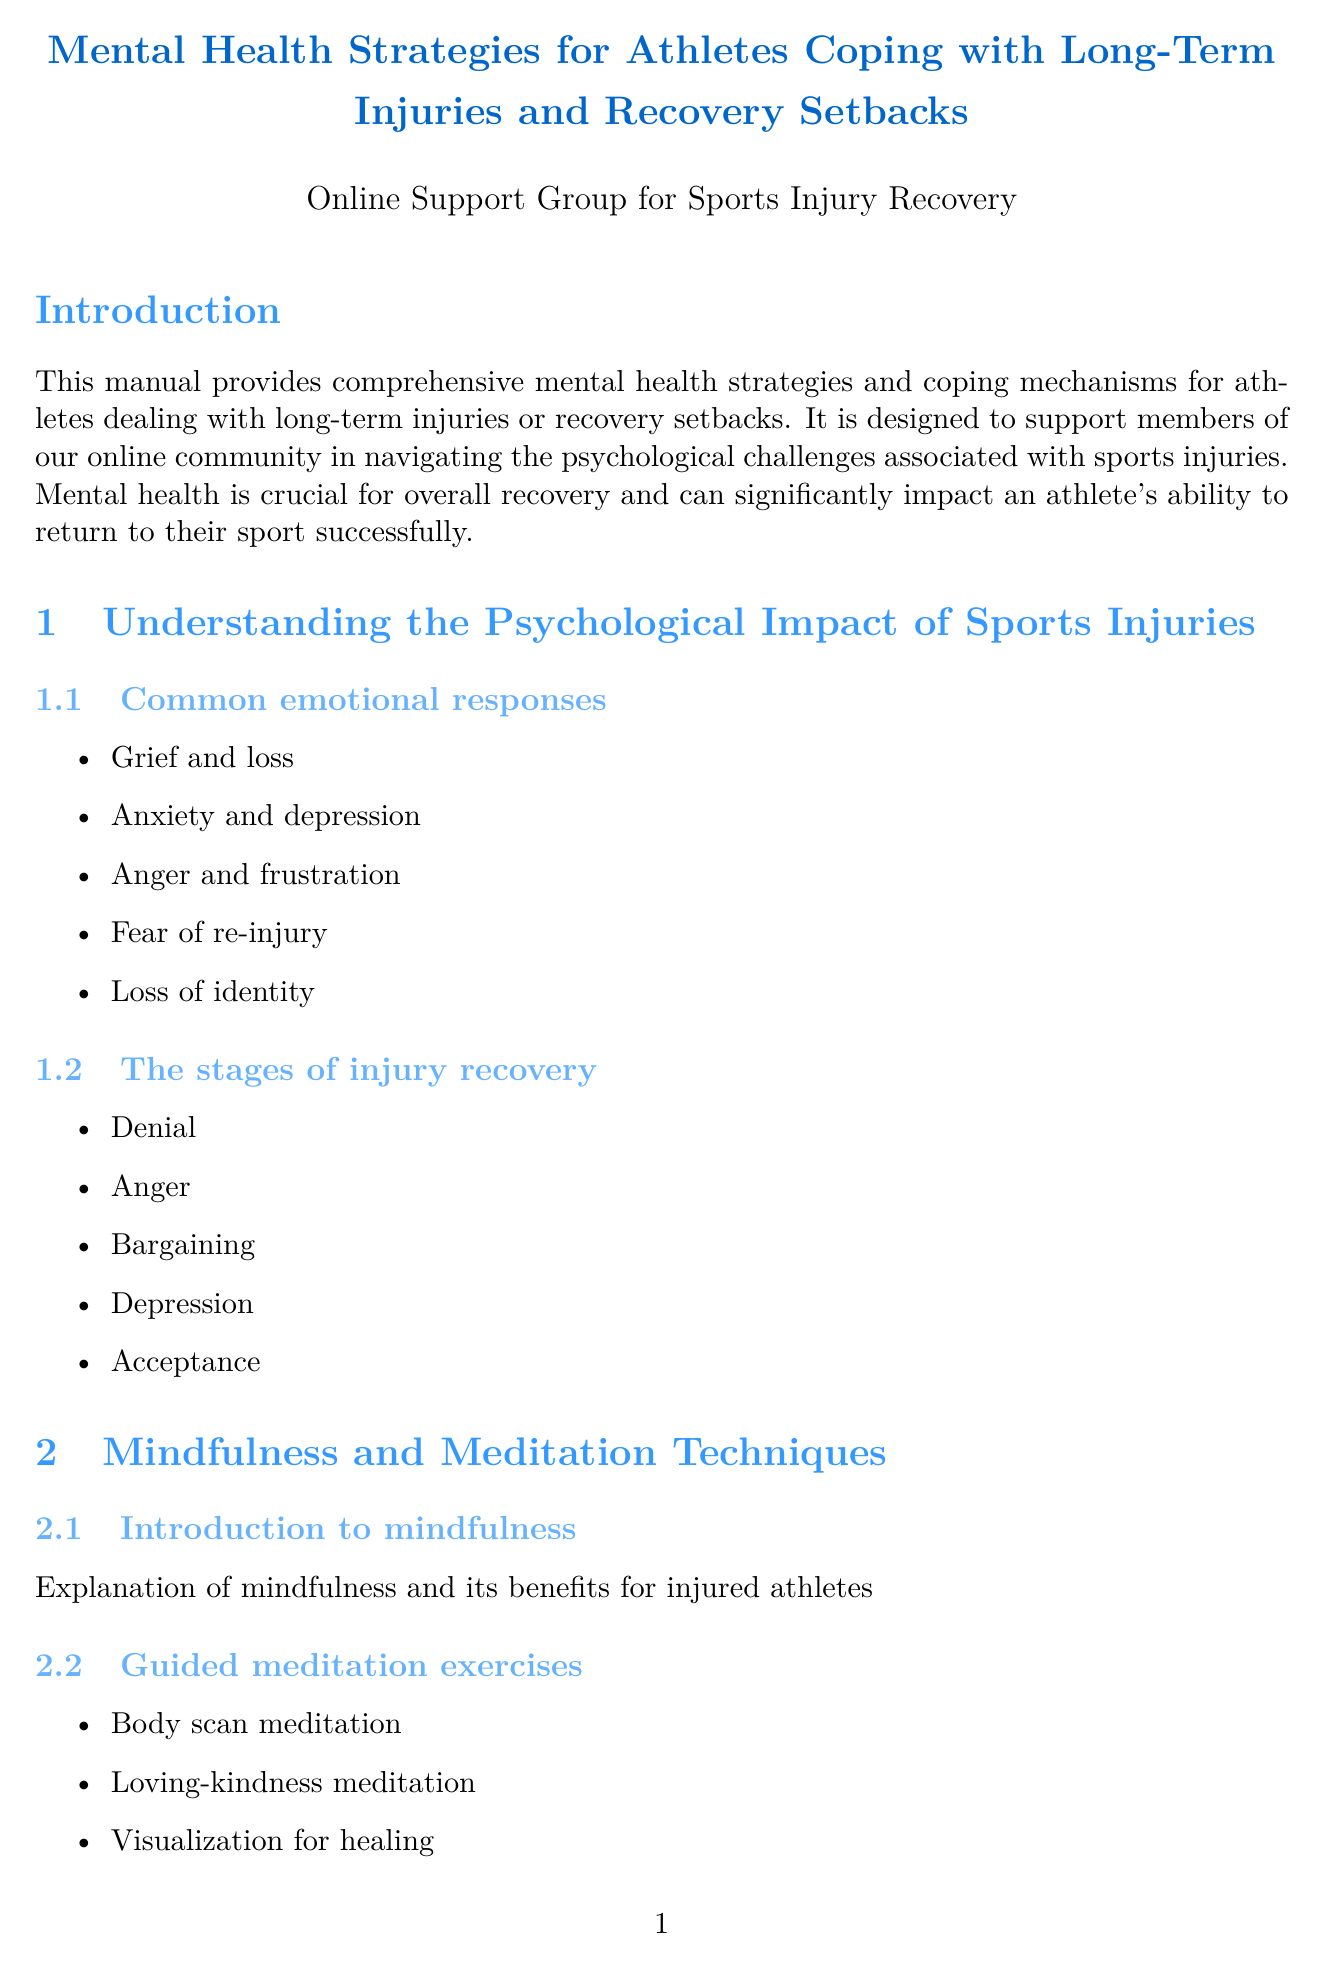What is the title of the manual? The title of the manual is provided in the document's title section.
Answer: Mental Health Strategies for Athletes Coping with Long-Term Injuries and Recovery Setbacks What are the common emotional responses to sports injuries? The document lists common emotional responses in a specific section.
Answer: Grief and loss, Anxiety and depression, Anger and frustration, Fear of re-injury, Loss of identity How many stages of injury recovery are mentioned? The document outlines a specific number of stages in the recovery section.
Answer: Five What is one technique mentioned for cognitive restructuring? The document specifies techniques related to cognitive restructuring under CBT techniques.
Answer: Techniques for reframing negative thoughts into more balanced, realistic ones Name one mindfulness app listed in the document. The document includes a section that lists mindfulness apps and resources.
Answer: Headspace What is a benefit of joining support groups? The document explains the benefits of peer support in the support network section.
Answer: Benefits of peer support What type of professionals can provide mental health support? The document lists types of mental health professionals in a designated section.
Answer: Sports psychologists, Clinical psychologists, Psychiatrists, Licensed counselors What holistic approach is discussed for pain management? The document mentions specific alternative therapies in the holistic approaches chapter.
Answer: Acupuncture for pain management and stress relief 